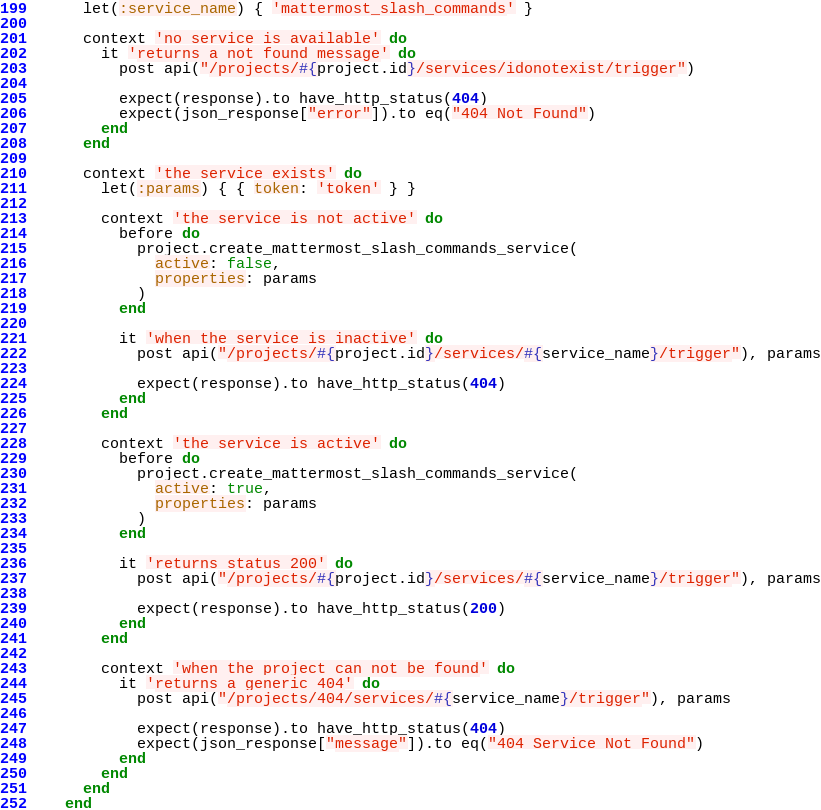<code> <loc_0><loc_0><loc_500><loc_500><_Ruby_>      let(:service_name) { 'mattermost_slash_commands' }

      context 'no service is available' do
        it 'returns a not found message' do
          post api("/projects/#{project.id}/services/idonotexist/trigger")

          expect(response).to have_http_status(404)
          expect(json_response["error"]).to eq("404 Not Found")
        end
      end

      context 'the service exists' do
        let(:params) { { token: 'token' } }

        context 'the service is not active' do
          before do
            project.create_mattermost_slash_commands_service(
              active: false,
              properties: params
            )
          end

          it 'when the service is inactive' do
            post api("/projects/#{project.id}/services/#{service_name}/trigger"), params

            expect(response).to have_http_status(404)
          end
        end

        context 'the service is active' do
          before do
            project.create_mattermost_slash_commands_service(
              active: true,
              properties: params
            )
          end

          it 'returns status 200' do
            post api("/projects/#{project.id}/services/#{service_name}/trigger"), params

            expect(response).to have_http_status(200)
          end
        end

        context 'when the project can not be found' do
          it 'returns a generic 404' do
            post api("/projects/404/services/#{service_name}/trigger"), params

            expect(response).to have_http_status(404)
            expect(json_response["message"]).to eq("404 Service Not Found")
          end
        end
      end
    end
</code> 